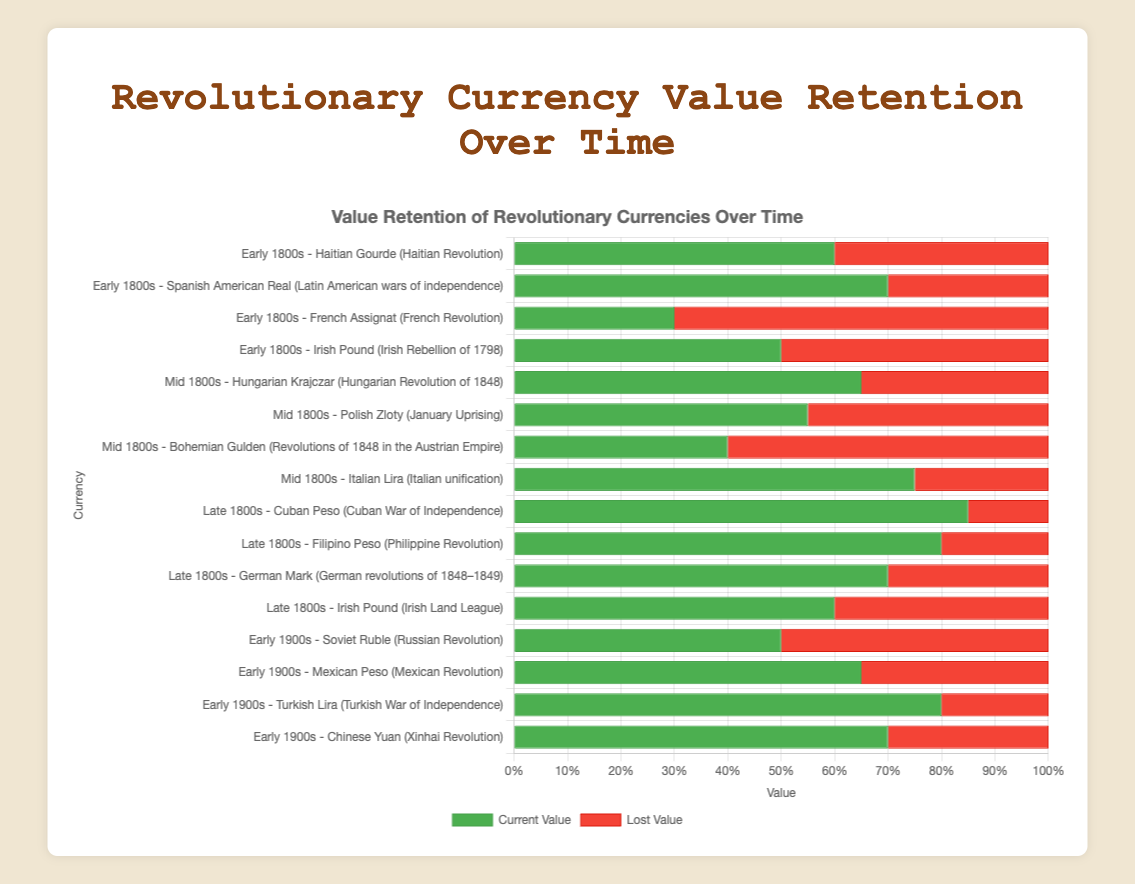Which currency from the Early 1800s has the highest current value? Identify the era 'Early 1800s' in the figure, and observe the bar lengths representing current values; the 'Spanish American Real' has the longest bar.
Answer: Spanish American Real (Latin American wars of independence) Among currencies from the Late 1800s, which one lost the most value? Find the Late 1800s section, then locate the bars representing lost value (red). Compare all red bars; the 'Irish Pound' has the longest red bar.
Answer: Irish Pound (Irish Land League) What is the average current value of currencies from the Early 1900s? Sum the current values of 'Soviet Ruble', 'Mexican Peso', 'Turkish Lira', and 'Chinese Yuan' (50 + 65 + 80 + 70) and divide by 4.
Answer: 66.25 Which currency across all eras retained exactly 50% of its value? Look for bars where the current value (green) is half the total (green + red); 'Soviet Ruble' has a green bar half the total length.
Answer: Soviet Ruble (Russian Revolution) Comparing the Mid 1800s and Early 1900s, which era has a currency with the lowest current value? Find the minimum current values in both eras by comparing green bar lengths; 'Bohemian Gulden' from the Mid 1800s has the shortest.
Answer: Mid 1800s What's the total value lost by all currencies listed for the Late 1800s? Sum the lost values (initial - current) for each currency in Late 1800s: 'Cuban Peso' (15), 'Filipino Peso' (20), 'German Mark' (30), 'Irish Pound' (40). Sum: 15 + 20 + 30 + 40.
Answer: 105 Which currency from the Mid 1800s has the highest current value? In the Mid 1800s section, observe the lengths of green bars representing current values; the 'Italian Lira' has the longest green bar.
Answer: Italian Lira (Italian unification) How much more value does the Cuban Peso retain compared to the Bohemian Gulden? Calculate the difference in current values between 'Cuban Peso' (85) and 'Bohemian Gulden' (40). 85 - 40.
Answer: 45 